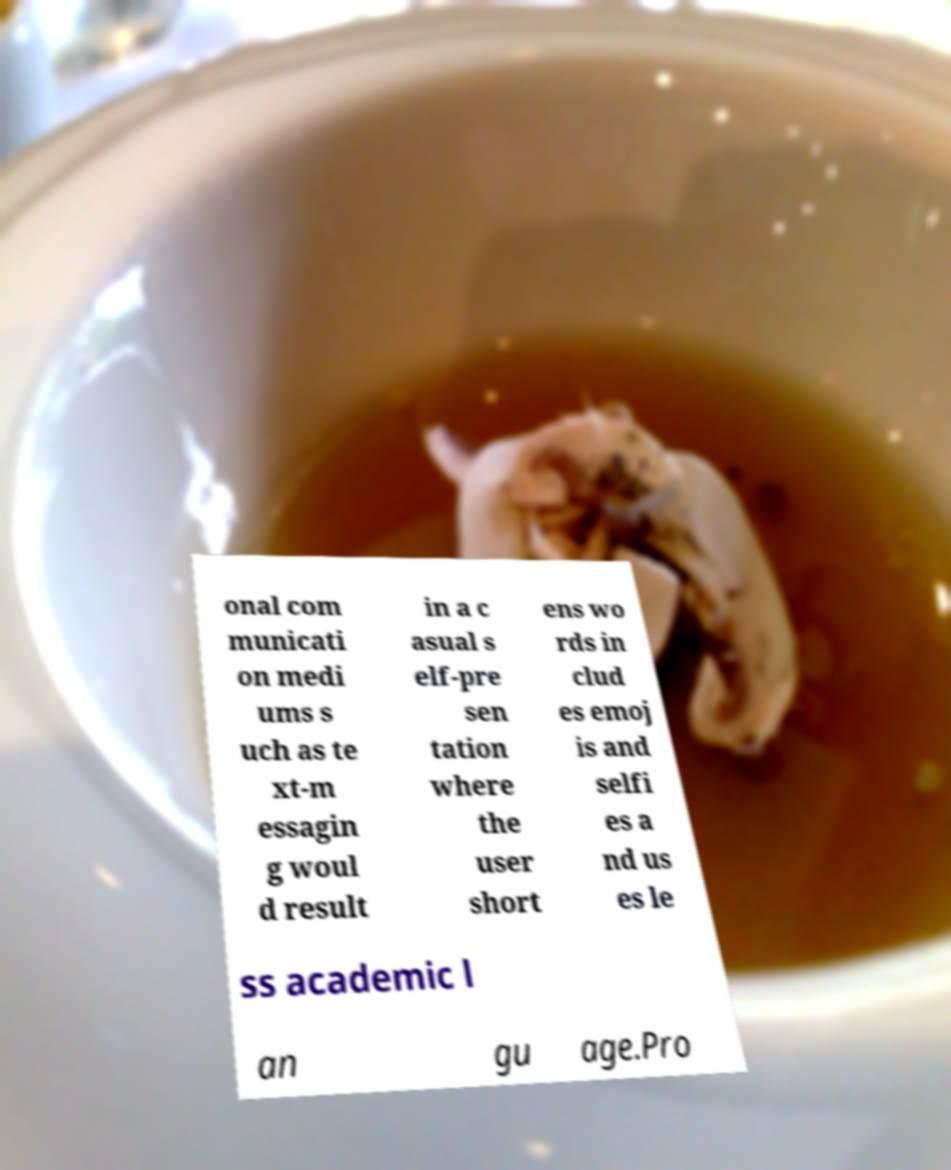Please read and relay the text visible in this image. What does it say? onal com municati on medi ums s uch as te xt-m essagin g woul d result in a c asual s elf-pre sen tation where the user short ens wo rds in clud es emoj is and selfi es a nd us es le ss academic l an gu age.Pro 